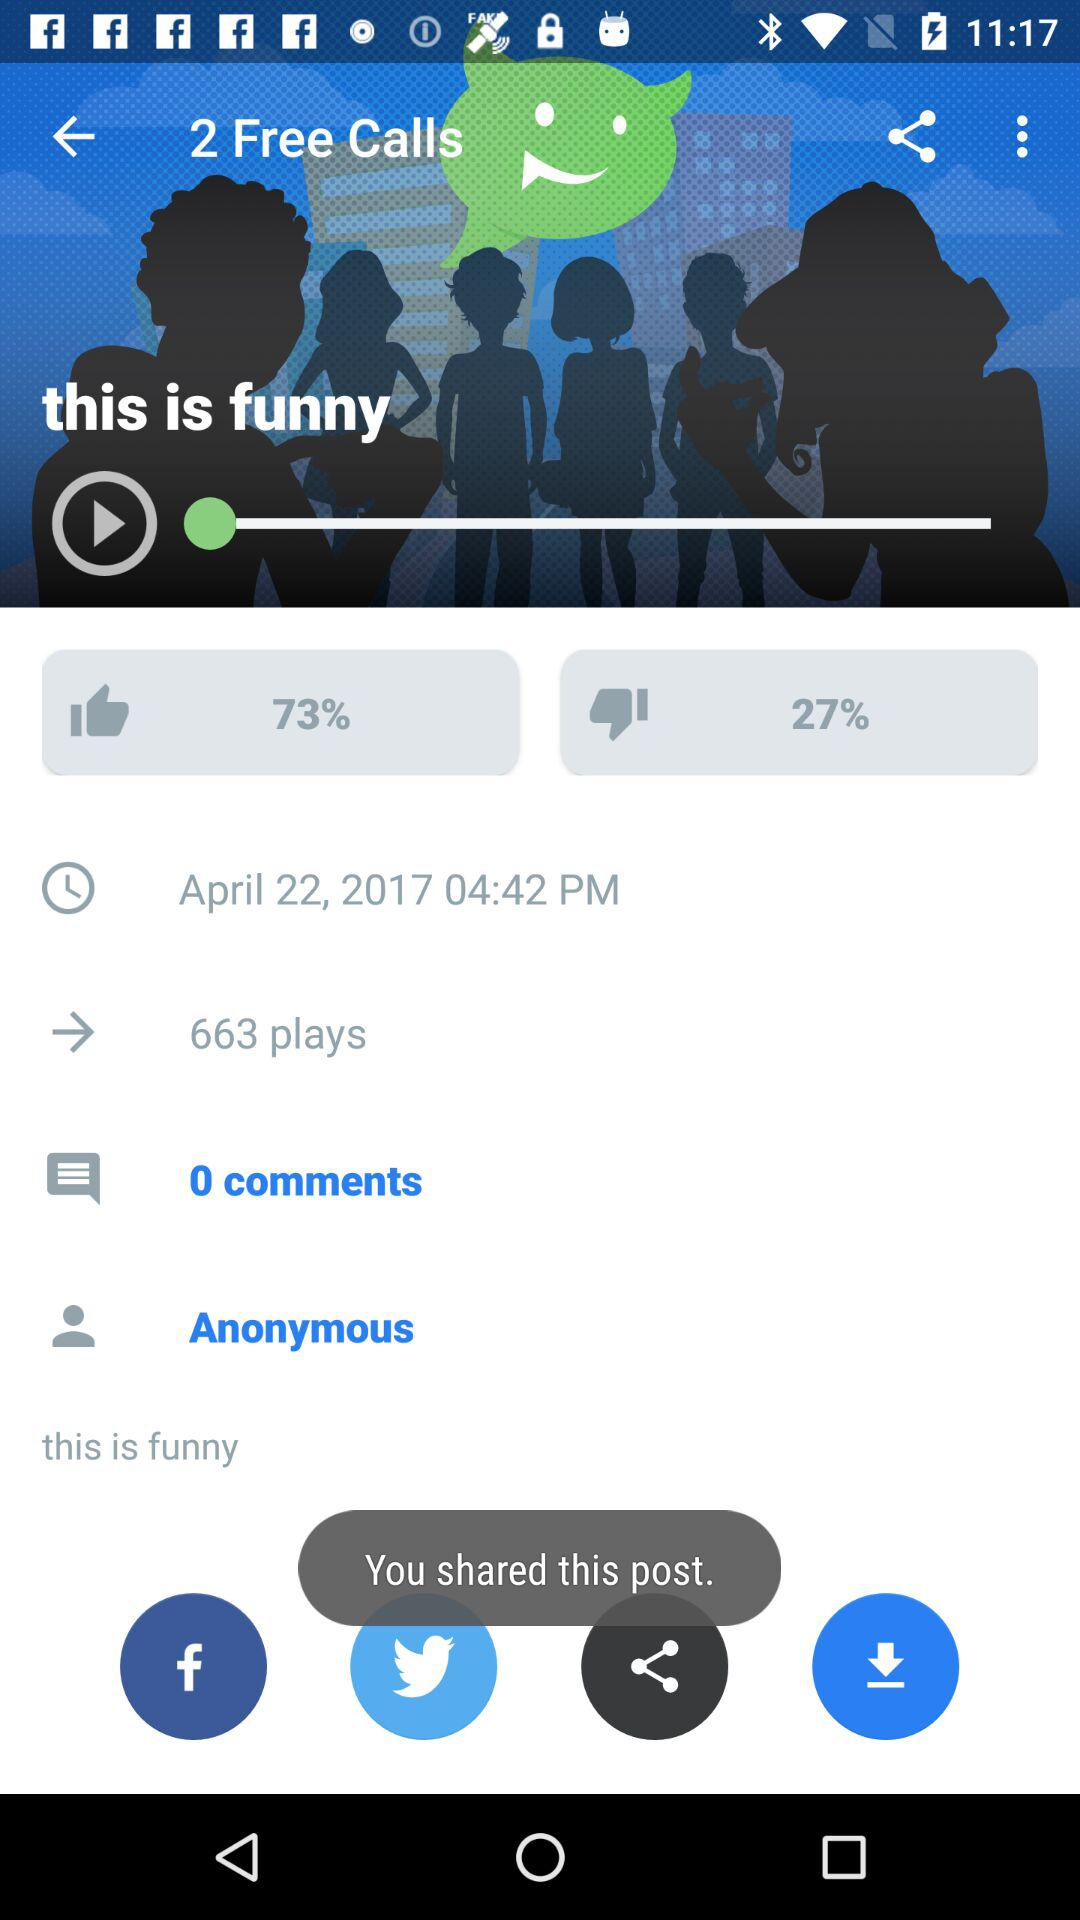How many free calls are there? There are 2 free calls. 